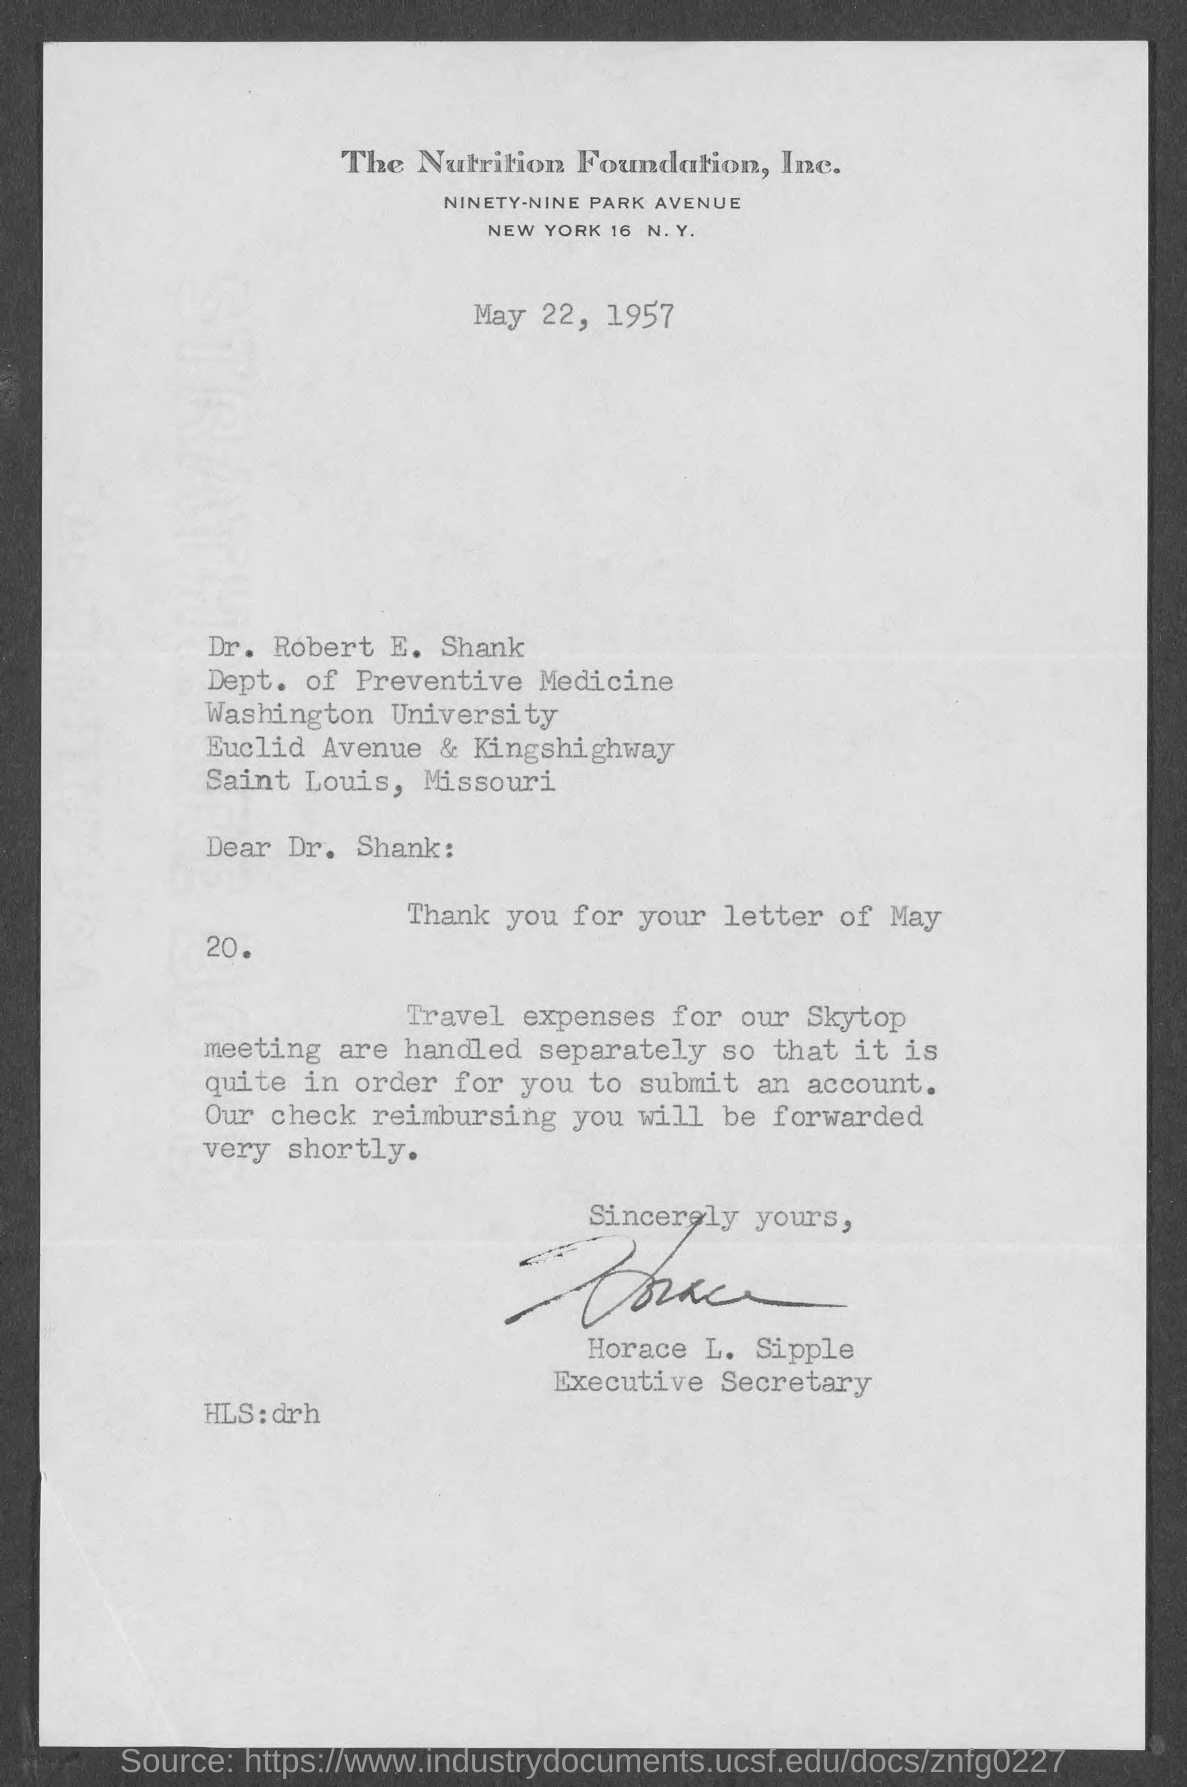What is the date on the document?
Provide a succinct answer. May 22, 1957. To Whom is this letter addressed to?
Provide a succinct answer. Dr. Shank. Who is this letter from?
Provide a short and direct response. Horace l. sipple. Travel expense for what are handled separately?
Offer a very short reply. Skytop meeting. 